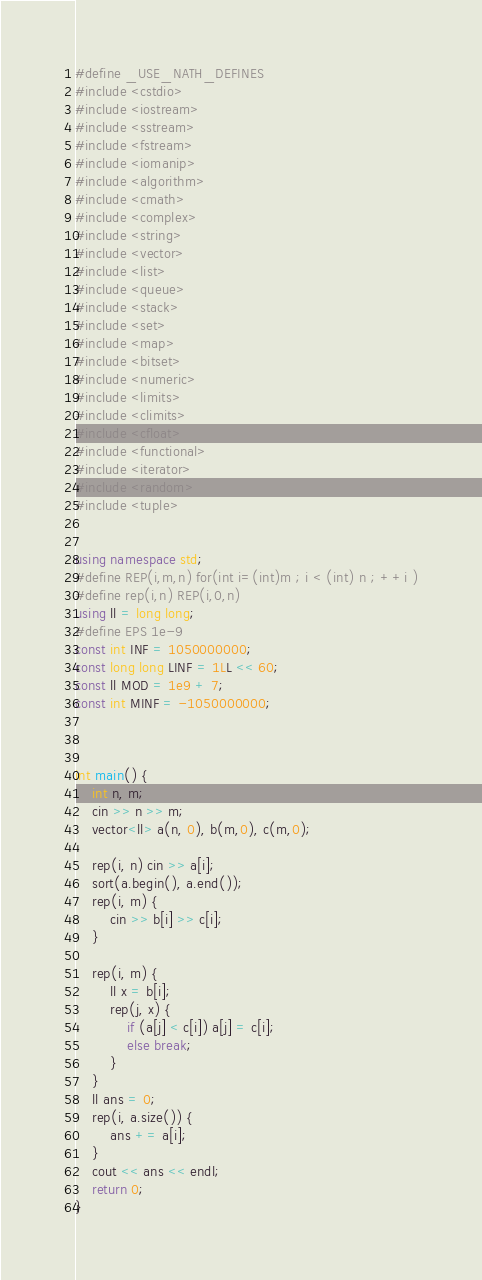<code> <loc_0><loc_0><loc_500><loc_500><_C++_>#define _USE_NATH_DEFINES
#include <cstdio>
#include <iostream>
#include <sstream>
#include <fstream>
#include <iomanip>
#include <algorithm>
#include <cmath>
#include <complex>
#include <string>
#include <vector>
#include <list>
#include <queue>
#include <stack>
#include <set>
#include <map>
#include <bitset>
#include <numeric>
#include <limits>
#include <climits>
#include <cfloat>
#include <functional>
#include <iterator>
#include <random>
#include <tuple>


using namespace std;
#define REP(i,m,n) for(int i=(int)m ; i < (int) n ; ++i )
#define rep(i,n) REP(i,0,n)
using ll = long long;
#define EPS 1e-9
const int INF = 1050000000;
const long long LINF = 1LL << 60;
const ll MOD = 1e9 + 7;
const int MINF = -1050000000;



int main() {
	int n, m;
	cin >> n >> m;
	vector<ll> a(n, 0), b(m,0), c(m,0);

	rep(i, n) cin >> a[i];
	sort(a.begin(), a.end());
	rep(i, m) {
		cin >> b[i] >> c[i];
	}

	rep(i, m) {
		ll x = b[i];
		rep(j, x) {
			if (a[j] < c[i]) a[j] = c[i];
			else break;
		}
	}
	ll ans = 0;
	rep(i, a.size()) {
		ans += a[i];
	}
	cout << ans << endl;
	return 0;
}
</code> 